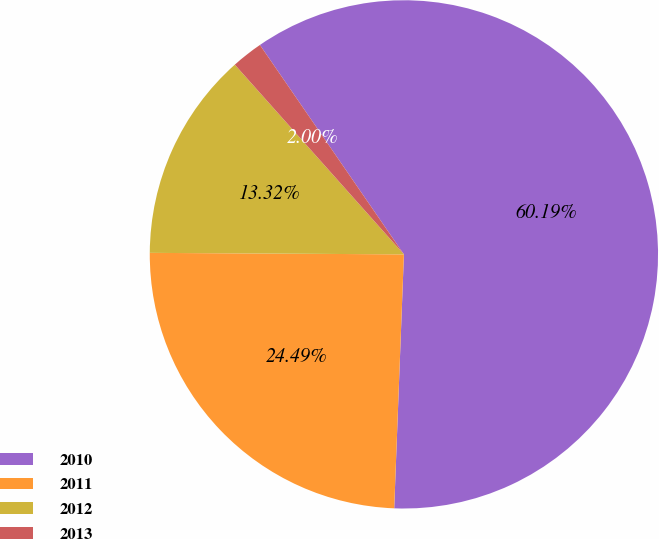<chart> <loc_0><loc_0><loc_500><loc_500><pie_chart><fcel>2010<fcel>2011<fcel>2012<fcel>2013<nl><fcel>60.2%<fcel>24.49%<fcel>13.32%<fcel>2.0%<nl></chart> 